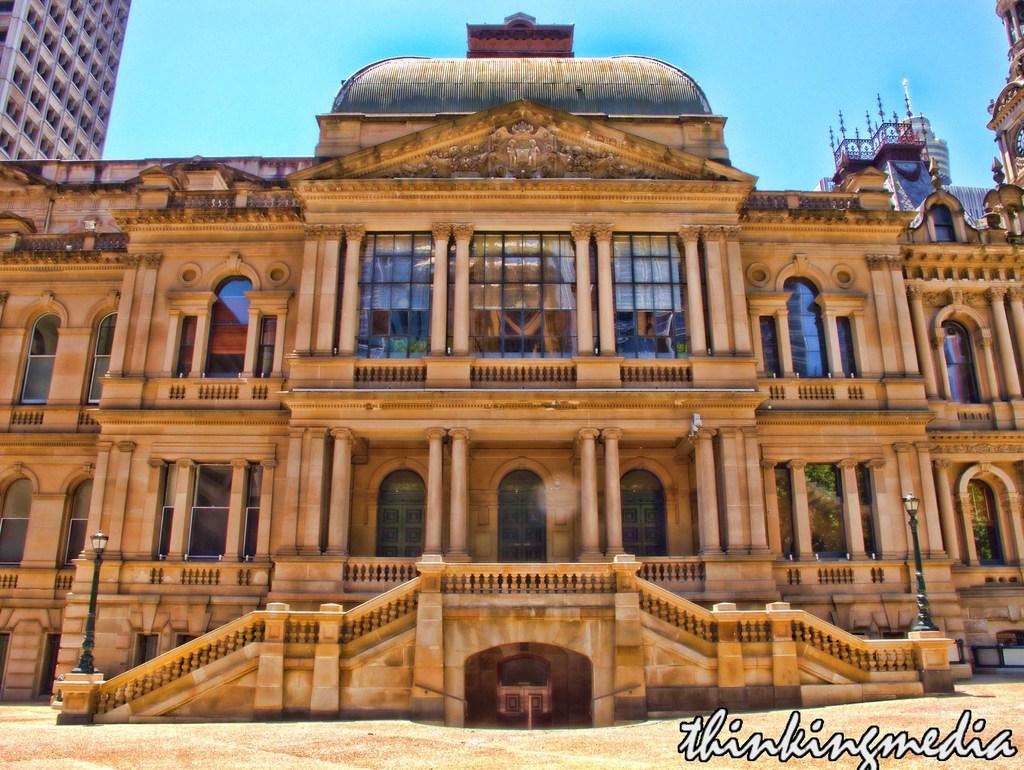<image>
Give a short and clear explanation of the subsequent image. Thinking Media is watermarked on the bottom of this building photo. 